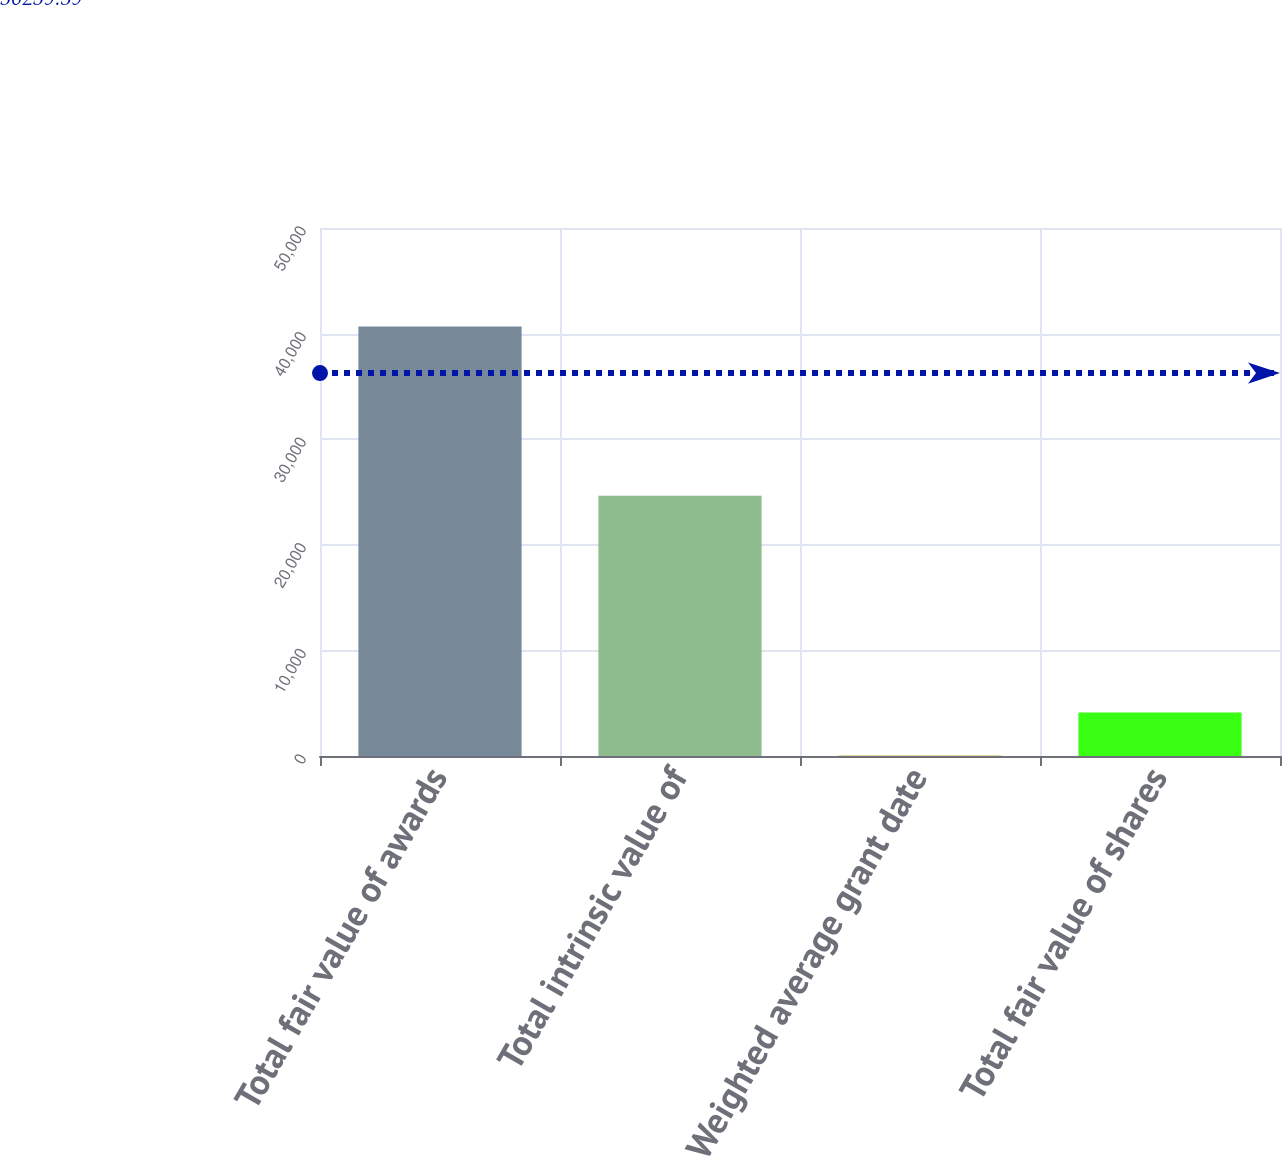Convert chart. <chart><loc_0><loc_0><loc_500><loc_500><bar_chart><fcel>Total fair value of awards<fcel>Total intrinsic value of<fcel>Weighted average grant date<fcel>Total fair value of shares<nl><fcel>40675<fcel>24652<fcel>52.79<fcel>4115.01<nl></chart> 